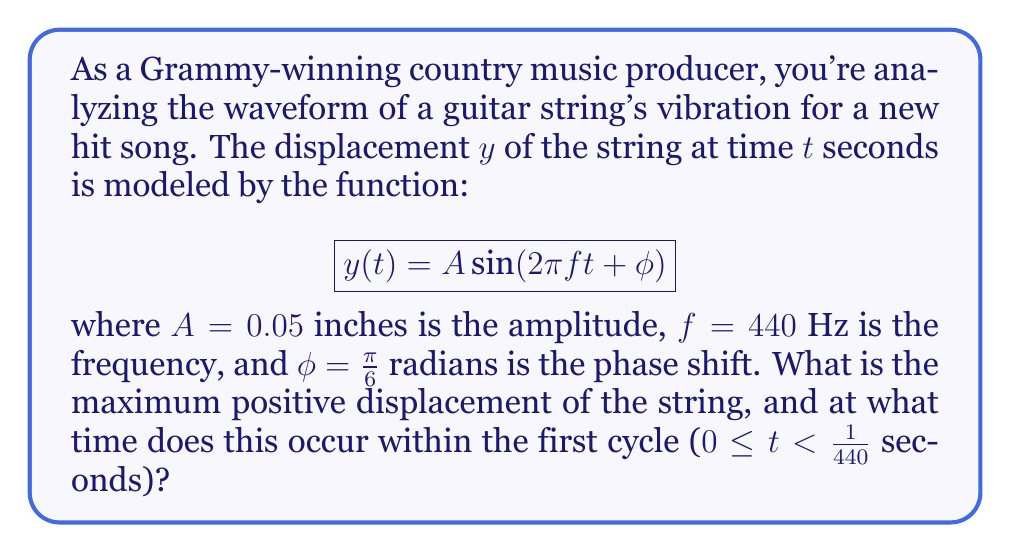Can you solve this math problem? To solve this problem, we need to follow these steps:

1) The maximum positive displacement of the string is equal to the amplitude $A$, which is given as 0.05 inches.

2) To find the time when this maximum occurs, we need to determine when the sine function reaches its maximum value of 1. This happens when the argument of the sine function equals $\frac{\pi}{2}$ radians (or 90°).

3) Let's set up the equation:

   $$2\pi ft + \phi = \frac{\pi}{2}$$

4) Substitute the known values:

   $$2\pi(440)t + \frac{\pi}{6} = \frac{\pi}{2}$$

5) Solve for $t$:

   $$880\pi t = \frac{\pi}{2} - \frac{\pi}{6} = \frac{\pi}{3}$$

   $$t = \frac{\pi}{3} \cdot \frac{1}{880\pi} = \frac{1}{2640} \approx 0.000379 \text{ seconds}$$

6) We need to verify if this time falls within the first cycle. The period of one cycle is:

   $$T = \frac{1}{f} = \frac{1}{440} \approx 0.002273 \text{ seconds}$$

   Indeed, $\frac{1}{2640} < \frac{1}{440}$, so our solution is within the first cycle.
Answer: The maximum positive displacement is 0.05 inches, occurring at $t = \frac{1}{2640}$ seconds (approximately 0.000379 seconds) within the first cycle. 